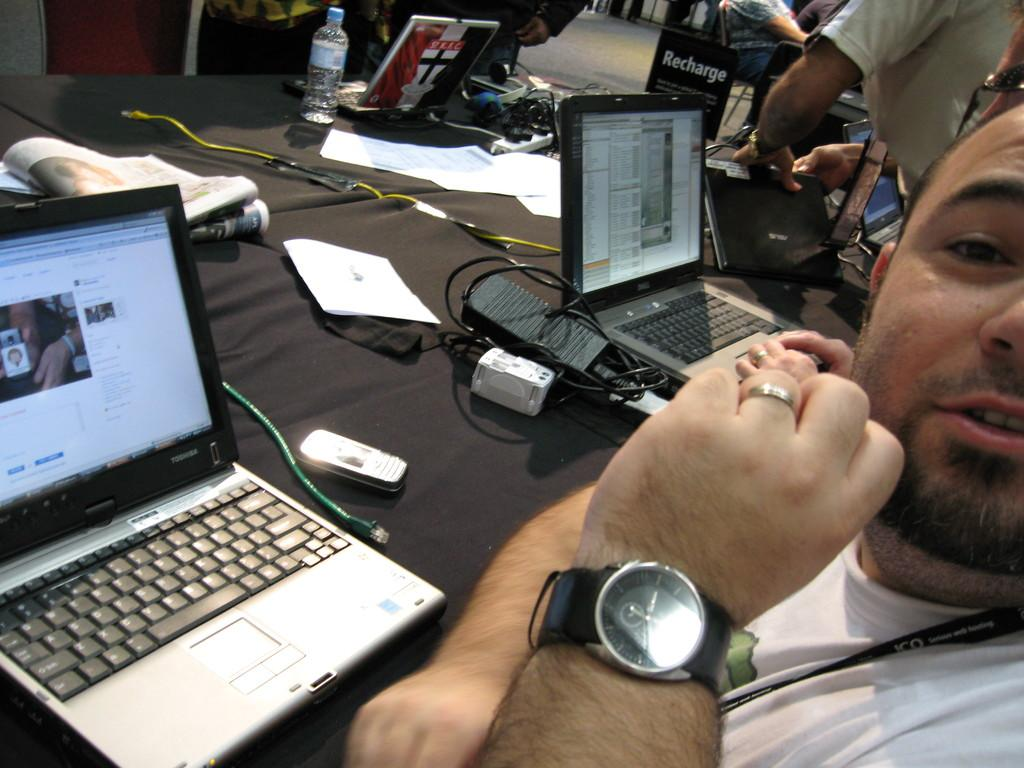<image>
Provide a brief description of the given image. A man that is sitting in front of a computer laptop looking at the camera. 